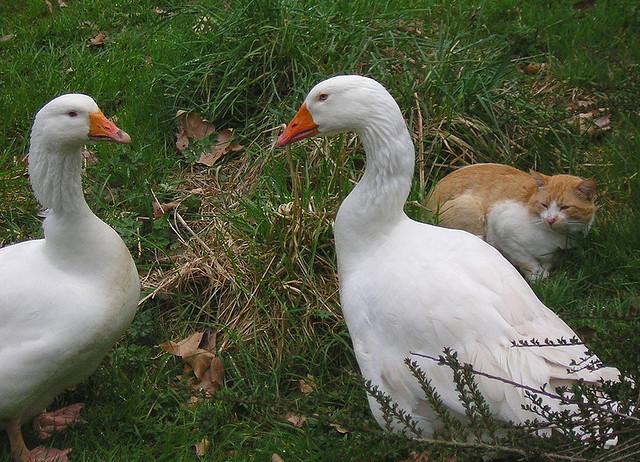What color is the underside of the cat in the picture?
Concise answer only. White. Are the ducks looking at each other?
Quick response, please. Yes. How many different kinds of animals are in this picture?
Concise answer only. 2. What are these birds?
Concise answer only. Ducks. 